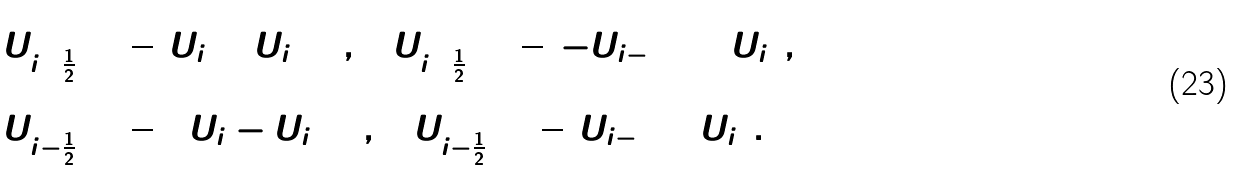Convert formula to latex. <formula><loc_0><loc_0><loc_500><loc_500>& U ^ { ( 0 ) } _ { i + \frac { 1 } { 2 } } = \frac { 1 } { 2 } ( U _ { i } + U _ { i + 1 } ) , \quad U ^ { ( 1 ) } _ { i + \frac { 1 } { 2 } } = \frac { 1 } { 2 } ( - U _ { i - 1 } + 3 U _ { i } ) , \\ & U ^ { ( 0 ) } _ { i - \frac { 1 } { 2 } } = \frac { 1 } { 2 } ( 3 U _ { i } - U _ { i + 1 } ) , \quad U ^ { ( 1 ) } _ { i - \frac { 1 } { 2 } } = \frac { 1 } { 2 } ( U _ { i - 1 } + U _ { i } ) .</formula> 